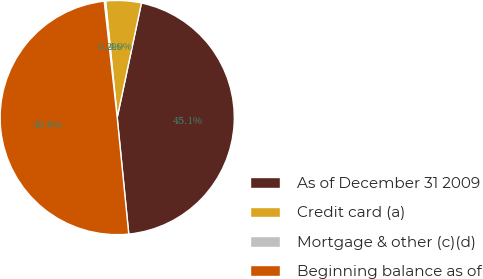Convert chart to OTSL. <chart><loc_0><loc_0><loc_500><loc_500><pie_chart><fcel>As of December 31 2009<fcel>Credit card (a)<fcel>Mortgage & other (c)(d)<fcel>Beginning balance as of<nl><fcel>45.11%<fcel>4.89%<fcel>0.2%<fcel>49.8%<nl></chart> 